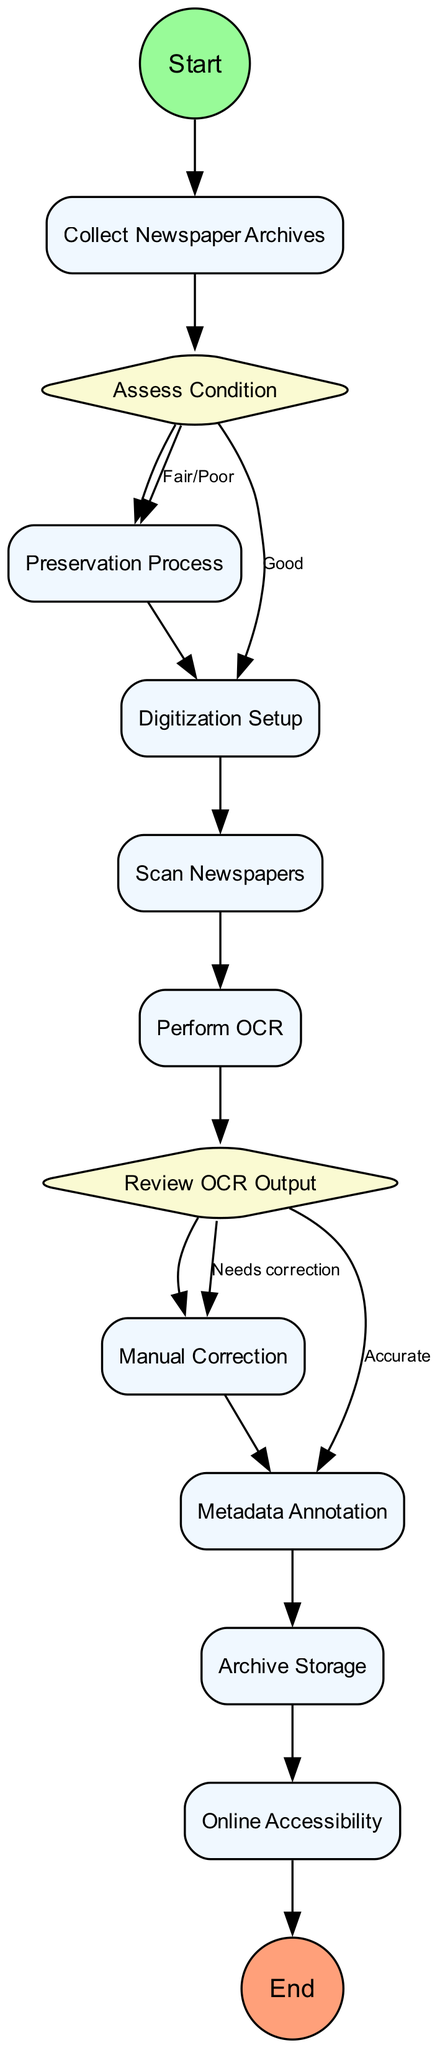What is the first step in the process? The first step in the process is represented by the "Start" node.
Answer: Start How many decision nodes are present in the diagram? The diagram contains two decision nodes: "Assess Condition" and "Review OCR Output".
Answer: 2 What action follows the "Scan Newspapers" node? The action that follows the "Scan Newspapers" node is "Perform OCR".
Answer: Perform OCR What happens to newspapers categorized as 'Good' in the condition assessment? Newspapers categorized as 'Good' bypass the "Preservation Process" and move directly to "Digitization Setup".
Answer: Digitization Setup In the "Review OCR Output" decision, what is the next action if the output is accurate? If the OCR output is accurate, the next action is "Metadata Annotation".
Answer: Metadata Annotation How many actions are there in total from start to end? There are 10 action nodes in total from start to end: the actions include collecting, preserving, setting up, scanning, performing OCR, correcting, annotating, archiving, and ensuring online accessibility.
Answer: 10 What is the last action before the project concludes? The last action before the project concludes is "Online Accessibility".
Answer: Online Accessibility If the condition of physical newspapers is 'Poor', what action should be taken? If the condition is 'Poor', the relevant action is "Preservation Process".
Answer: Preservation Process What type of node is "End"? The node "End" is classified as an "End Event".
Answer: End Event 